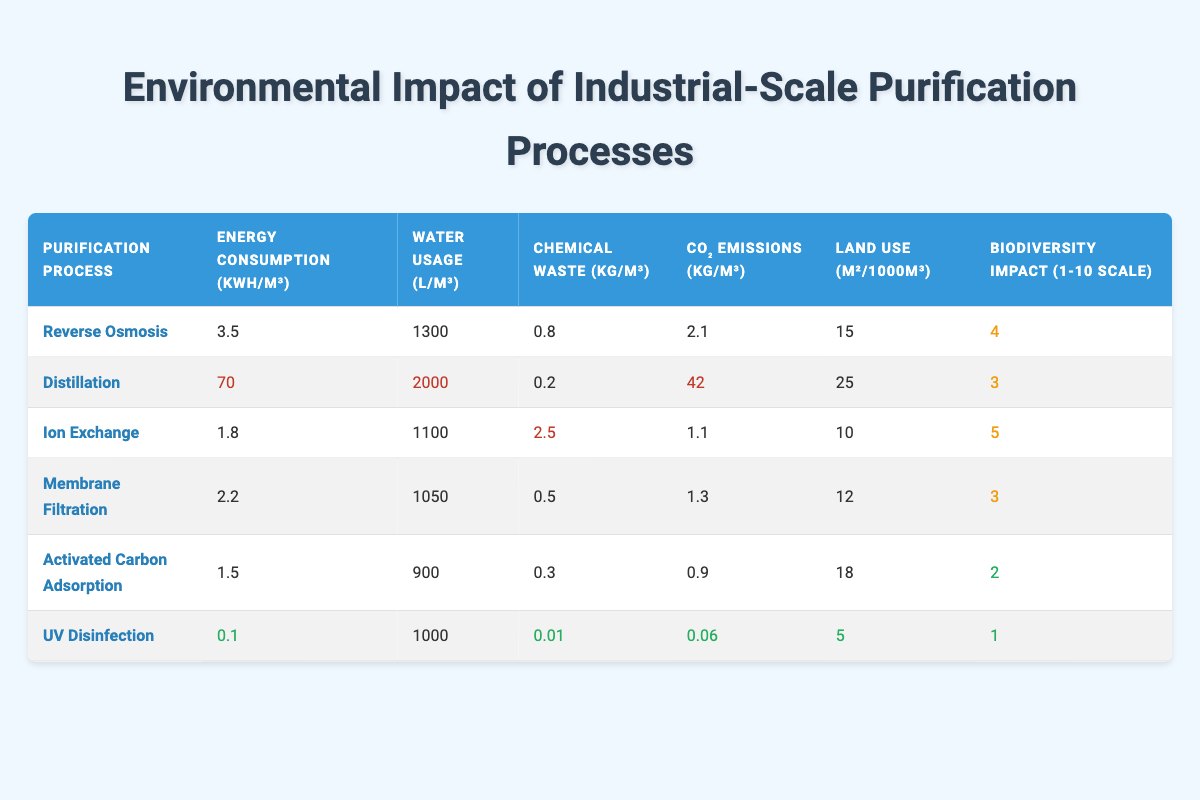What is the energy consumption of UV disinfection? The table shows the energy consumption for each purification process. For UV disinfection, it is listed as 0.1 kWh/m³.
Answer: 0.1 kWh/m³ Which purification process has the highest CO₂ emissions? By comparing the CO₂ emissions values in the table, we see that distillation has the highest emissions at 42 kg/m³.
Answer: Distillation What is the average water usage across all purification processes? To find the average, we sum the water usage (1300 + 2000 + 1100 + 1050 + 900 + 1000 = 8350 L/m³) and divide by 6 (the number of processes). The average is 8350 / 6 = 1391.67 L/m³.
Answer: 1391.67 L/m³ Does activated carbon adsorption have a higher biodiversity impact than reverse osmosis? Looking at the biodiversity impact scores in the table, activated carbon adsorption has a score of 2, while reverse osmosis has a score of 4. Since 2 is less than 4, the statement is false.
Answer: No Which purification process has the lowest energy consumption? Comparing the energy consumption values in the table, activated carbon adsorption shows the lowest at 1.5 kWh/m³.
Answer: Activated Carbon Adsorption What is the difference in land use between distillation and ion exchange? Distillation requires 25 m²/1000m³ and ion exchange requires 10 m²/1000m³. The difference is 25 - 10 = 15 m²/1000m³.
Answer: 15 m²/1000m³ Is there a purification process that utilizes less than 1000 L of water per cubic meter? By examining the water usage data, we see that activated carbon adsorption uses 900 L/m³, which is under 1000 L. Thus, there is a process that meets this criterion.
Answer: Yes What is the total chemical waste produced by all purification processes? Summing the chemical waste values from each process: (0.8 + 0.2 + 2.5 + 0.5 + 0.3 + 0.01 = 4.31 kg/m³). Therefore, the total chemical waste is 4.31 kg/m³.
Answer: 4.31 kg/m³ 